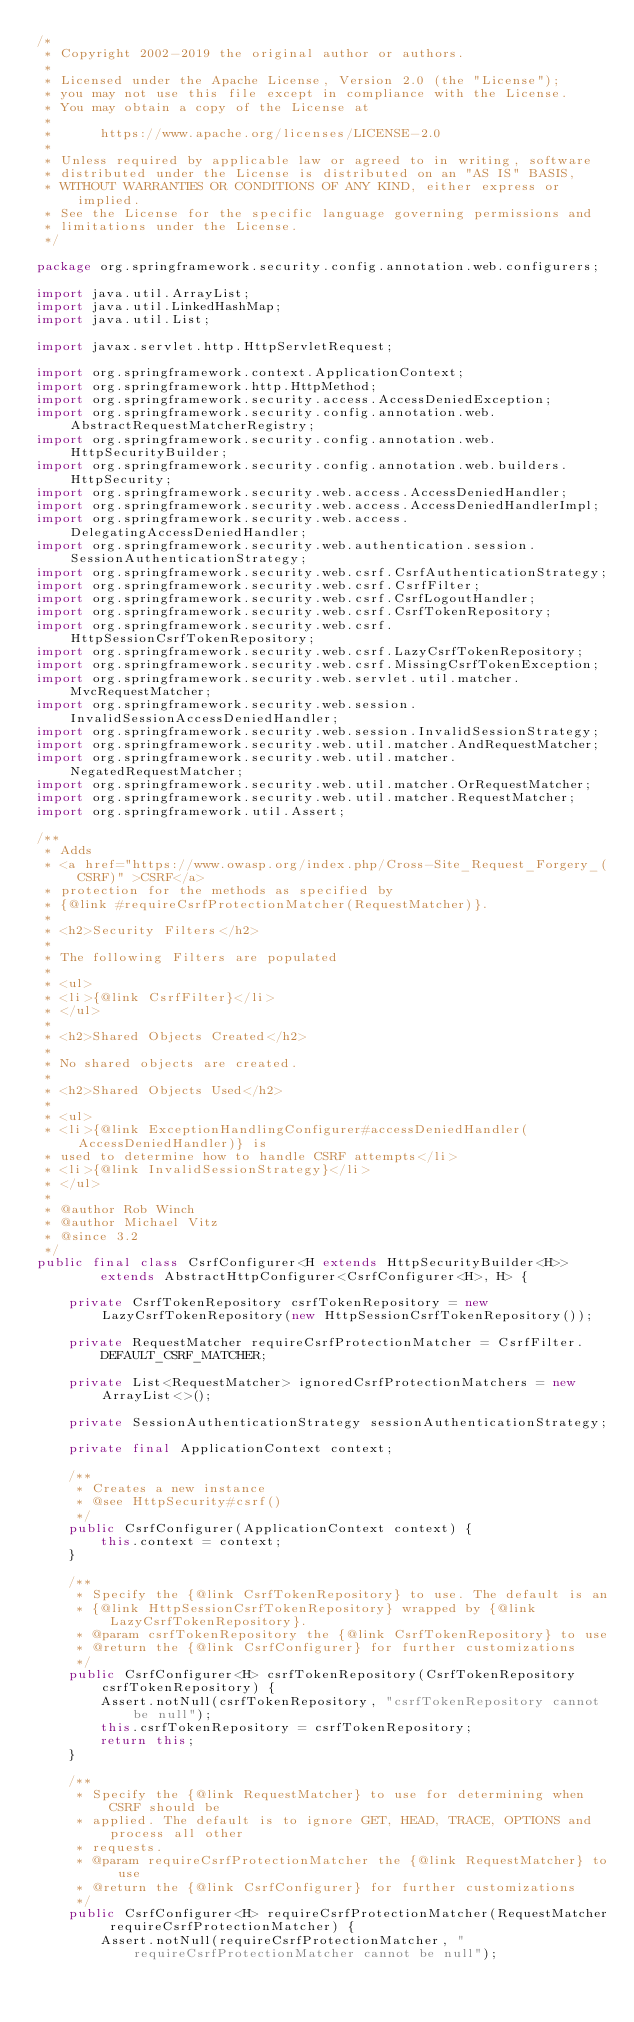Convert code to text. <code><loc_0><loc_0><loc_500><loc_500><_Java_>/*
 * Copyright 2002-2019 the original author or authors.
 *
 * Licensed under the Apache License, Version 2.0 (the "License");
 * you may not use this file except in compliance with the License.
 * You may obtain a copy of the License at
 *
 *      https://www.apache.org/licenses/LICENSE-2.0
 *
 * Unless required by applicable law or agreed to in writing, software
 * distributed under the License is distributed on an "AS IS" BASIS,
 * WITHOUT WARRANTIES OR CONDITIONS OF ANY KIND, either express or implied.
 * See the License for the specific language governing permissions and
 * limitations under the License.
 */

package org.springframework.security.config.annotation.web.configurers;

import java.util.ArrayList;
import java.util.LinkedHashMap;
import java.util.List;

import javax.servlet.http.HttpServletRequest;

import org.springframework.context.ApplicationContext;
import org.springframework.http.HttpMethod;
import org.springframework.security.access.AccessDeniedException;
import org.springframework.security.config.annotation.web.AbstractRequestMatcherRegistry;
import org.springframework.security.config.annotation.web.HttpSecurityBuilder;
import org.springframework.security.config.annotation.web.builders.HttpSecurity;
import org.springframework.security.web.access.AccessDeniedHandler;
import org.springframework.security.web.access.AccessDeniedHandlerImpl;
import org.springframework.security.web.access.DelegatingAccessDeniedHandler;
import org.springframework.security.web.authentication.session.SessionAuthenticationStrategy;
import org.springframework.security.web.csrf.CsrfAuthenticationStrategy;
import org.springframework.security.web.csrf.CsrfFilter;
import org.springframework.security.web.csrf.CsrfLogoutHandler;
import org.springframework.security.web.csrf.CsrfTokenRepository;
import org.springframework.security.web.csrf.HttpSessionCsrfTokenRepository;
import org.springframework.security.web.csrf.LazyCsrfTokenRepository;
import org.springframework.security.web.csrf.MissingCsrfTokenException;
import org.springframework.security.web.servlet.util.matcher.MvcRequestMatcher;
import org.springframework.security.web.session.InvalidSessionAccessDeniedHandler;
import org.springframework.security.web.session.InvalidSessionStrategy;
import org.springframework.security.web.util.matcher.AndRequestMatcher;
import org.springframework.security.web.util.matcher.NegatedRequestMatcher;
import org.springframework.security.web.util.matcher.OrRequestMatcher;
import org.springframework.security.web.util.matcher.RequestMatcher;
import org.springframework.util.Assert;

/**
 * Adds
 * <a href="https://www.owasp.org/index.php/Cross-Site_Request_Forgery_(CSRF)" >CSRF</a>
 * protection for the methods as specified by
 * {@link #requireCsrfProtectionMatcher(RequestMatcher)}.
 *
 * <h2>Security Filters</h2>
 *
 * The following Filters are populated
 *
 * <ul>
 * <li>{@link CsrfFilter}</li>
 * </ul>
 *
 * <h2>Shared Objects Created</h2>
 *
 * No shared objects are created.
 *
 * <h2>Shared Objects Used</h2>
 *
 * <ul>
 * <li>{@link ExceptionHandlingConfigurer#accessDeniedHandler(AccessDeniedHandler)} is
 * used to determine how to handle CSRF attempts</li>
 * <li>{@link InvalidSessionStrategy}</li>
 * </ul>
 *
 * @author Rob Winch
 * @author Michael Vitz
 * @since 3.2
 */
public final class CsrfConfigurer<H extends HttpSecurityBuilder<H>>
		extends AbstractHttpConfigurer<CsrfConfigurer<H>, H> {

	private CsrfTokenRepository csrfTokenRepository = new LazyCsrfTokenRepository(new HttpSessionCsrfTokenRepository());

	private RequestMatcher requireCsrfProtectionMatcher = CsrfFilter.DEFAULT_CSRF_MATCHER;

	private List<RequestMatcher> ignoredCsrfProtectionMatchers = new ArrayList<>();

	private SessionAuthenticationStrategy sessionAuthenticationStrategy;

	private final ApplicationContext context;

	/**
	 * Creates a new instance
	 * @see HttpSecurity#csrf()
	 */
	public CsrfConfigurer(ApplicationContext context) {
		this.context = context;
	}

	/**
	 * Specify the {@link CsrfTokenRepository} to use. The default is an
	 * {@link HttpSessionCsrfTokenRepository} wrapped by {@link LazyCsrfTokenRepository}.
	 * @param csrfTokenRepository the {@link CsrfTokenRepository} to use
	 * @return the {@link CsrfConfigurer} for further customizations
	 */
	public CsrfConfigurer<H> csrfTokenRepository(CsrfTokenRepository csrfTokenRepository) {
		Assert.notNull(csrfTokenRepository, "csrfTokenRepository cannot be null");
		this.csrfTokenRepository = csrfTokenRepository;
		return this;
	}

	/**
	 * Specify the {@link RequestMatcher} to use for determining when CSRF should be
	 * applied. The default is to ignore GET, HEAD, TRACE, OPTIONS and process all other
	 * requests.
	 * @param requireCsrfProtectionMatcher the {@link RequestMatcher} to use
	 * @return the {@link CsrfConfigurer} for further customizations
	 */
	public CsrfConfigurer<H> requireCsrfProtectionMatcher(RequestMatcher requireCsrfProtectionMatcher) {
		Assert.notNull(requireCsrfProtectionMatcher, "requireCsrfProtectionMatcher cannot be null");</code> 